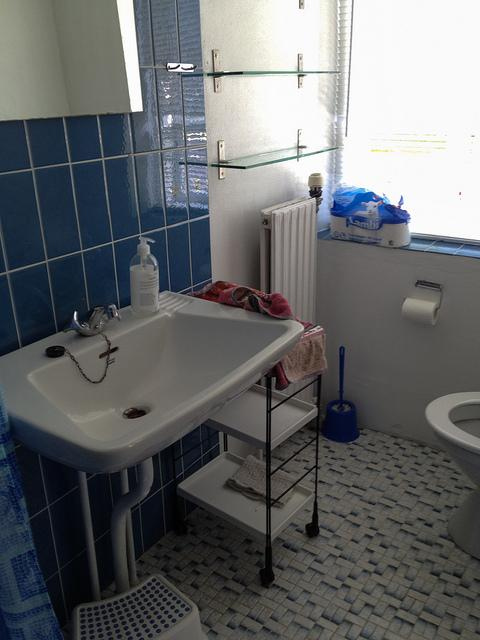What is usually done here? wash hands 